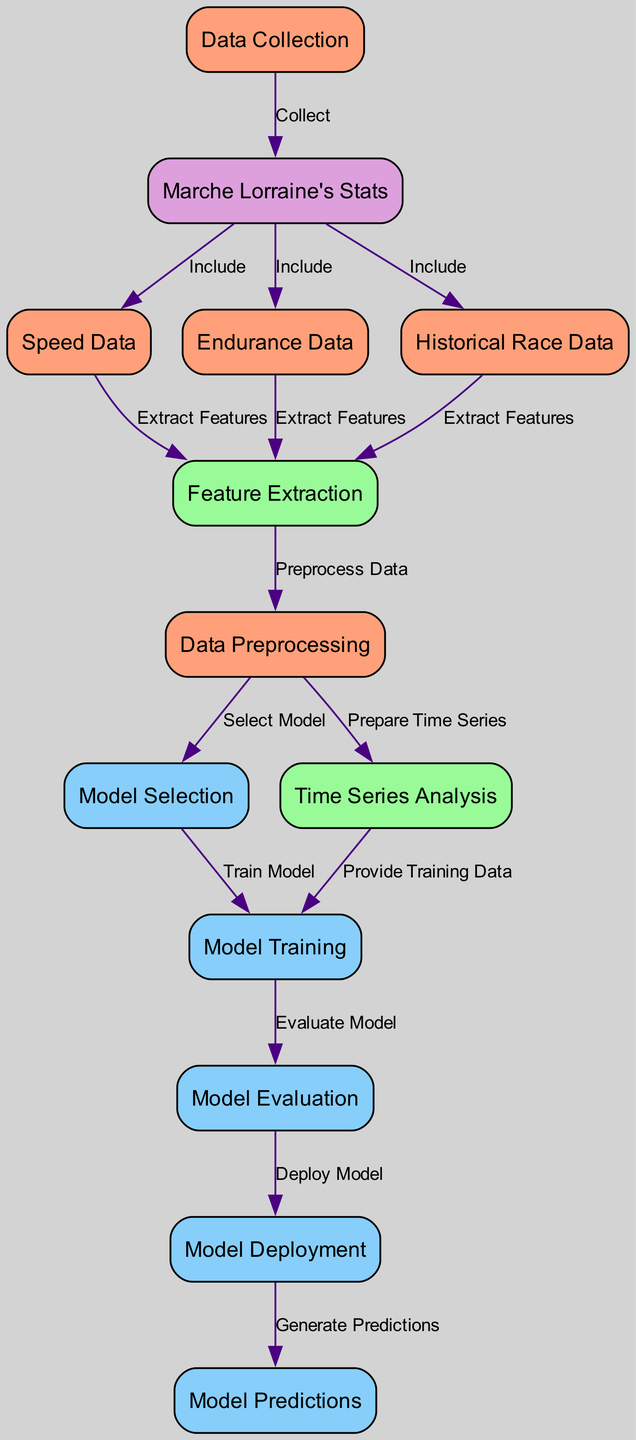What is the starting point of the diagram? The diagram begins with the node labeled "Data Collection." This is the first step indicating where the process initiates, as shown by the incoming edges.
Answer: Data Collection How many nodes are in the diagram? By counting all the unique nodes listed in the diagram, we find that there are 13 nodes total, as indicated in the data structure.
Answer: 13 What data type is included before feature extraction? The edges from "Marche Lorraine's Stats" indicate that "Speed Data," "Endurance Data," and "Historical Race Data" are all included as input before proceeding to feature extraction.
Answer: Speed Data, Endurance Data, Historical Race Data Identify the two processes that lead to model training. The two processes leading to "Model Training" are "Model Selection" and "Time Series Analysis." The flow indicates they are integral stages before training the model.
Answer: Model Selection, Time Series Analysis What happens immediately after model evaluation? The next process following "Model Evaluation" is "Model Deployment," indicating that once the model has been evaluated, it proceeds to be deployed.
Answer: Model Deployment Which data is used to prepare time series analysis? The node "Data Preprocessing" provides the data required for "Time Series Analysis," illustrating a clear path in the diagram flow.
Answer: Data Preprocessing What is the connection between historical race data and feature extraction? The edge labeled "Extract Features" from "Historical Race Data" to "Feature Extraction" shows that historical data helps derive necessary features for further analysis.
Answer: Extract Features What is the final output of the model deployment phase? The graph indicates that after "Model Deployment," the output generated is "Model Predictions," which represents the ultimate outcome of the previous processes.
Answer: Model Predictions Which node provides training data for the model training phase? The node "Time Series Analysis" provides the necessary training data for "Model Training," as indicated by the connecting edge in the diagram.
Answer: Time Series Analysis How is data preprocessed according to the diagram? The diagram highlights "Feature Extraction" as a process that is initiated from the various data sets, which subsequently leads to "Data Preprocessing," suggesting that preprocessing occurs after feature extraction.
Answer: Preprocess Data 